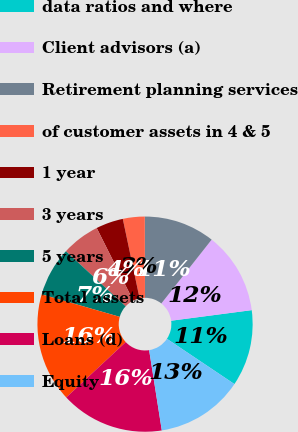Convert chart to OTSL. <chart><loc_0><loc_0><loc_500><loc_500><pie_chart><fcel>data ratios and where<fcel>Client advisors (a)<fcel>Retirement planning services<fcel>of customer assets in 4 & 5<fcel>1 year<fcel>3 years<fcel>5 years<fcel>Total assets<fcel>Loans (d)<fcel>Equity<nl><fcel>11.48%<fcel>12.3%<fcel>10.66%<fcel>3.28%<fcel>4.1%<fcel>5.74%<fcel>7.38%<fcel>16.39%<fcel>15.57%<fcel>13.11%<nl></chart> 